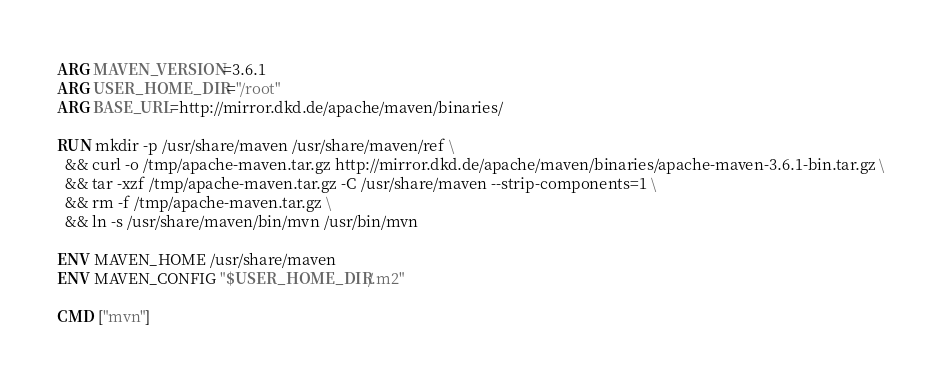<code> <loc_0><loc_0><loc_500><loc_500><_Dockerfile_>
ARG MAVEN_VERSION=3.6.1
ARG USER_HOME_DIR="/root"
ARG BASE_URL=http://mirror.dkd.de/apache/maven/binaries/

RUN mkdir -p /usr/share/maven /usr/share/maven/ref \
  && curl -o /tmp/apache-maven.tar.gz http://mirror.dkd.de/apache/maven/binaries/apache-maven-3.6.1-bin.tar.gz \
  && tar -xzf /tmp/apache-maven.tar.gz -C /usr/share/maven --strip-components=1 \
  && rm -f /tmp/apache-maven.tar.gz \
  && ln -s /usr/share/maven/bin/mvn /usr/bin/mvn

ENV MAVEN_HOME /usr/share/maven
ENV MAVEN_CONFIG "$USER_HOME_DIR/.m2"

CMD ["mvn"]</code> 